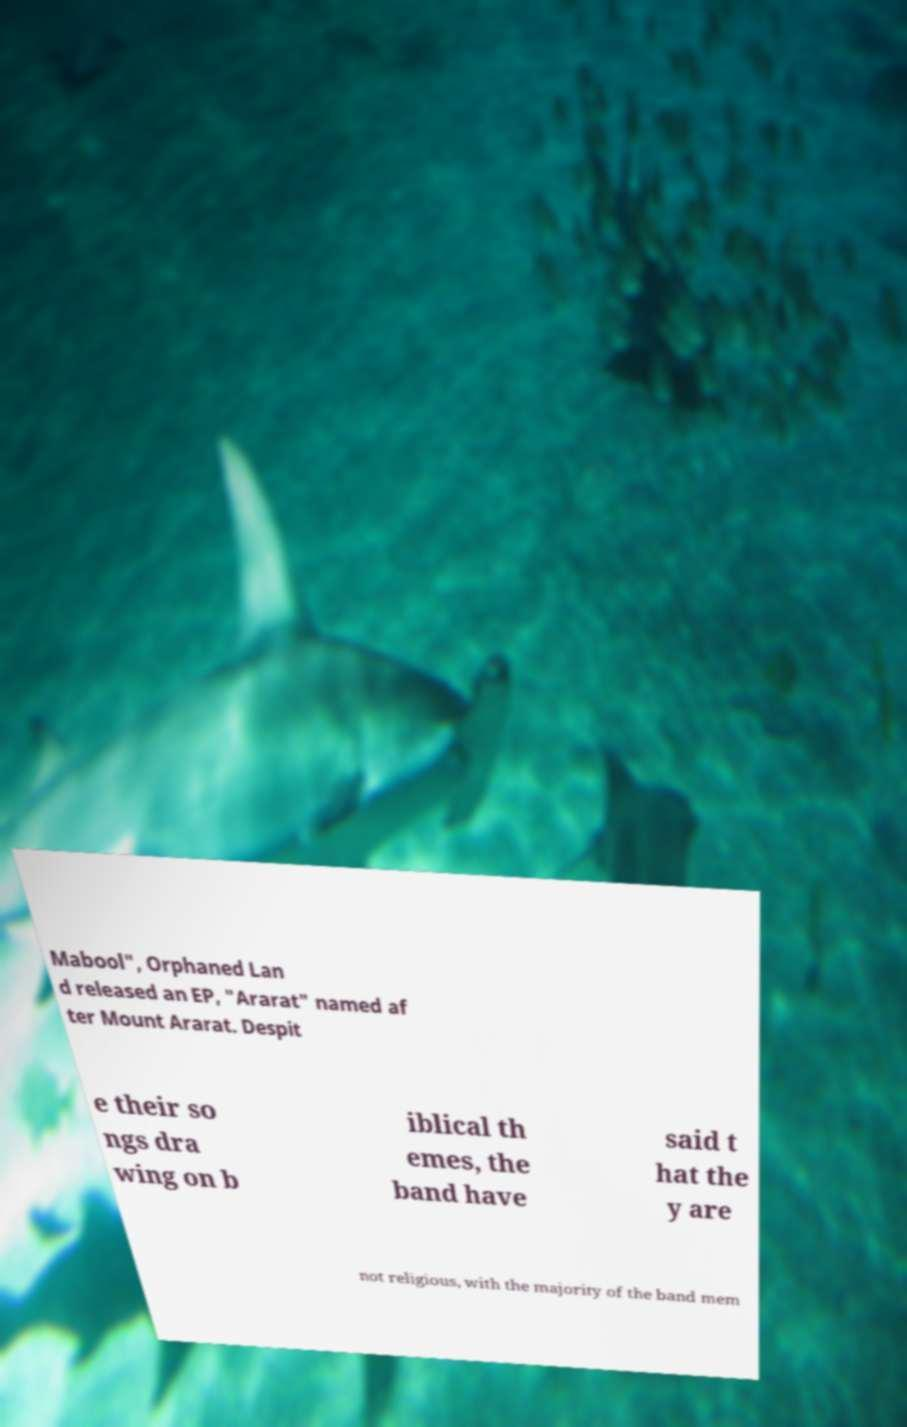What messages or text are displayed in this image? I need them in a readable, typed format. Mabool", Orphaned Lan d released an EP, "Ararat" named af ter Mount Ararat. Despit e their so ngs dra wing on b iblical th emes, the band have said t hat the y are not religious, with the majority of the band mem 